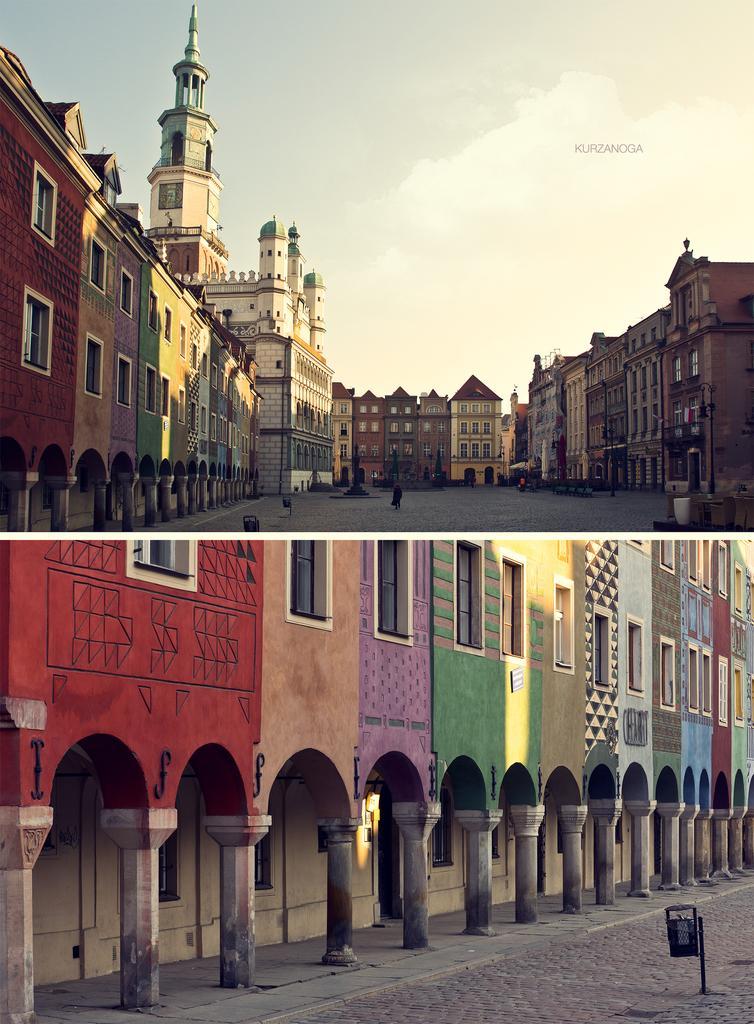How would you summarize this image in a sentence or two? This is a collage image. We can see some buildings and the ground with some objects. We can also see the sky and a person in the first part of the image. 